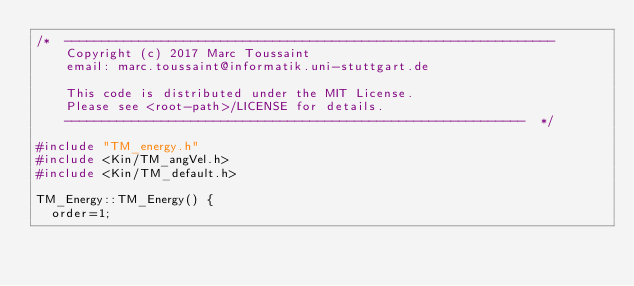Convert code to text. <code><loc_0><loc_0><loc_500><loc_500><_C++_>/*  ------------------------------------------------------------------
    Copyright (c) 2017 Marc Toussaint
    email: marc.toussaint@informatik.uni-stuttgart.de

    This code is distributed under the MIT License.
    Please see <root-path>/LICENSE for details.
    --------------------------------------------------------------  */

#include "TM_energy.h"
#include <Kin/TM_angVel.h>
#include <Kin/TM_default.h>

TM_Energy::TM_Energy() {
  order=1;</code> 